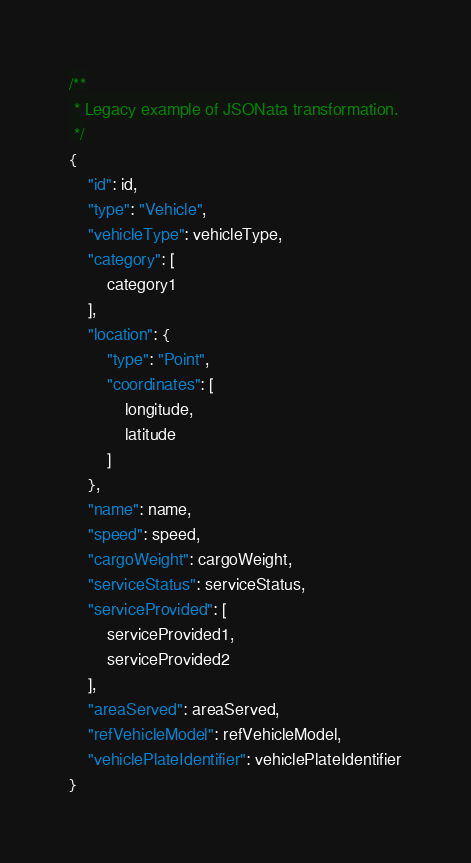<code> <loc_0><loc_0><loc_500><loc_500><_JavaScript_>/**
 * Legacy example of JSONata transformation.
 */
{
	"id": id,
	"type": "Vehicle",
	"vehicleType": vehicleType,
	"category": [
		category1
	],
	"location": {
		"type": "Point",
		"coordinates": [
			longitude,
			latitude
		]
	},
	"name": name,
	"speed": speed,
	"cargoWeight": cargoWeight,
	"serviceStatus": serviceStatus,
	"serviceProvided": [
		serviceProvided1,
		serviceProvided2
	],
	"areaServed": areaServed,
	"refVehicleModel": refVehicleModel,
	"vehiclePlateIdentifier": vehiclePlateIdentifier
}
</code> 